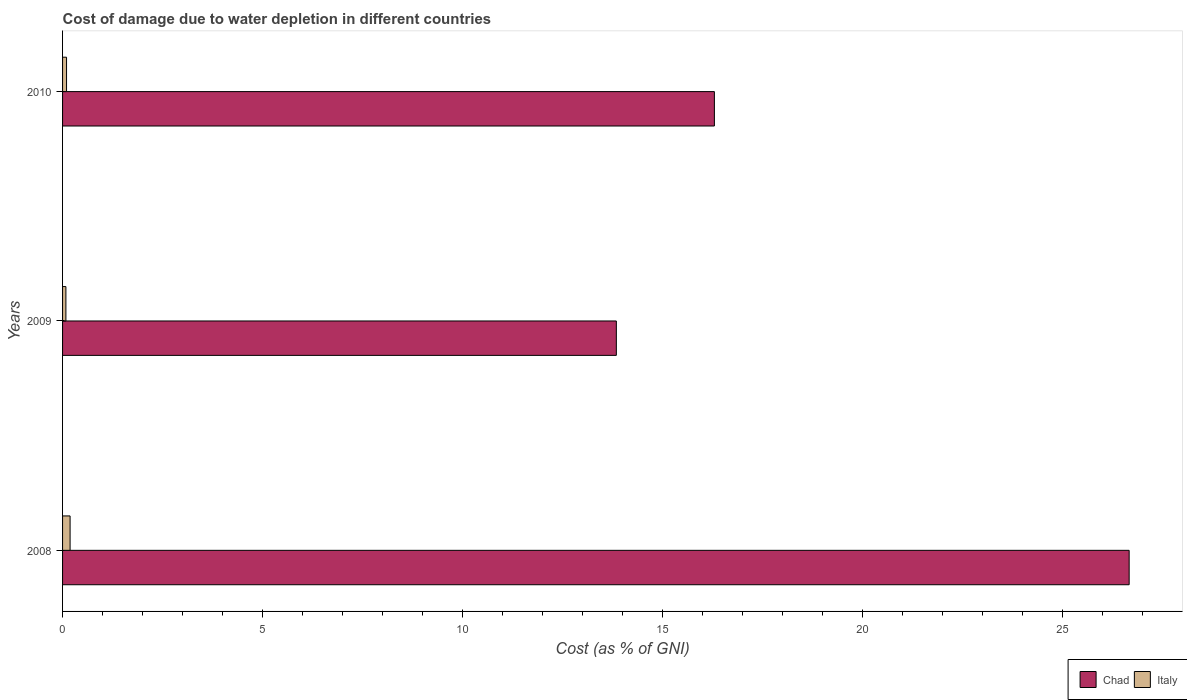How many groups of bars are there?
Your response must be concise. 3. Are the number of bars per tick equal to the number of legend labels?
Give a very brief answer. Yes. How many bars are there on the 3rd tick from the top?
Provide a short and direct response. 2. What is the label of the 1st group of bars from the top?
Give a very brief answer. 2010. In how many cases, is the number of bars for a given year not equal to the number of legend labels?
Ensure brevity in your answer.  0. What is the cost of damage caused due to water depletion in Italy in 2010?
Your response must be concise. 0.1. Across all years, what is the maximum cost of damage caused due to water depletion in Chad?
Make the answer very short. 26.66. Across all years, what is the minimum cost of damage caused due to water depletion in Chad?
Keep it short and to the point. 13.84. In which year was the cost of damage caused due to water depletion in Italy maximum?
Give a very brief answer. 2008. In which year was the cost of damage caused due to water depletion in Chad minimum?
Your answer should be compact. 2009. What is the total cost of damage caused due to water depletion in Chad in the graph?
Your response must be concise. 56.79. What is the difference between the cost of damage caused due to water depletion in Italy in 2008 and that in 2009?
Your response must be concise. 0.1. What is the difference between the cost of damage caused due to water depletion in Italy in 2009 and the cost of damage caused due to water depletion in Chad in 2008?
Your answer should be compact. -26.57. What is the average cost of damage caused due to water depletion in Italy per year?
Give a very brief answer. 0.12. In the year 2009, what is the difference between the cost of damage caused due to water depletion in Chad and cost of damage caused due to water depletion in Italy?
Your response must be concise. 13.76. What is the ratio of the cost of damage caused due to water depletion in Italy in 2008 to that in 2009?
Ensure brevity in your answer.  2.26. Is the difference between the cost of damage caused due to water depletion in Chad in 2009 and 2010 greater than the difference between the cost of damage caused due to water depletion in Italy in 2009 and 2010?
Give a very brief answer. No. What is the difference between the highest and the second highest cost of damage caused due to water depletion in Chad?
Your answer should be very brief. 10.37. What is the difference between the highest and the lowest cost of damage caused due to water depletion in Chad?
Keep it short and to the point. 12.82. In how many years, is the cost of damage caused due to water depletion in Chad greater than the average cost of damage caused due to water depletion in Chad taken over all years?
Offer a terse response. 1. Are all the bars in the graph horizontal?
Offer a very short reply. Yes. Does the graph contain any zero values?
Your response must be concise. No. Where does the legend appear in the graph?
Ensure brevity in your answer.  Bottom right. How many legend labels are there?
Your answer should be very brief. 2. How are the legend labels stacked?
Your answer should be very brief. Horizontal. What is the title of the graph?
Your answer should be compact. Cost of damage due to water depletion in different countries. Does "Iceland" appear as one of the legend labels in the graph?
Offer a very short reply. No. What is the label or title of the X-axis?
Provide a short and direct response. Cost (as % of GNI). What is the label or title of the Y-axis?
Offer a terse response. Years. What is the Cost (as % of GNI) of Chad in 2008?
Make the answer very short. 26.66. What is the Cost (as % of GNI) in Italy in 2008?
Offer a terse response. 0.19. What is the Cost (as % of GNI) in Chad in 2009?
Make the answer very short. 13.84. What is the Cost (as % of GNI) in Italy in 2009?
Your response must be concise. 0.08. What is the Cost (as % of GNI) in Chad in 2010?
Your response must be concise. 16.29. What is the Cost (as % of GNI) in Italy in 2010?
Provide a succinct answer. 0.1. Across all years, what is the maximum Cost (as % of GNI) in Chad?
Your answer should be compact. 26.66. Across all years, what is the maximum Cost (as % of GNI) of Italy?
Give a very brief answer. 0.19. Across all years, what is the minimum Cost (as % of GNI) of Chad?
Keep it short and to the point. 13.84. Across all years, what is the minimum Cost (as % of GNI) of Italy?
Your response must be concise. 0.08. What is the total Cost (as % of GNI) of Chad in the graph?
Provide a short and direct response. 56.79. What is the total Cost (as % of GNI) of Italy in the graph?
Ensure brevity in your answer.  0.37. What is the difference between the Cost (as % of GNI) of Chad in 2008 and that in 2009?
Provide a succinct answer. 12.82. What is the difference between the Cost (as % of GNI) of Italy in 2008 and that in 2009?
Keep it short and to the point. 0.1. What is the difference between the Cost (as % of GNI) in Chad in 2008 and that in 2010?
Offer a very short reply. 10.37. What is the difference between the Cost (as % of GNI) in Italy in 2008 and that in 2010?
Provide a succinct answer. 0.09. What is the difference between the Cost (as % of GNI) of Chad in 2009 and that in 2010?
Your answer should be very brief. -2.45. What is the difference between the Cost (as % of GNI) in Italy in 2009 and that in 2010?
Make the answer very short. -0.02. What is the difference between the Cost (as % of GNI) of Chad in 2008 and the Cost (as % of GNI) of Italy in 2009?
Offer a very short reply. 26.57. What is the difference between the Cost (as % of GNI) in Chad in 2008 and the Cost (as % of GNI) in Italy in 2010?
Keep it short and to the point. 26.56. What is the difference between the Cost (as % of GNI) in Chad in 2009 and the Cost (as % of GNI) in Italy in 2010?
Make the answer very short. 13.74. What is the average Cost (as % of GNI) in Chad per year?
Provide a succinct answer. 18.93. What is the average Cost (as % of GNI) in Italy per year?
Your answer should be compact. 0.12. In the year 2008, what is the difference between the Cost (as % of GNI) of Chad and Cost (as % of GNI) of Italy?
Your response must be concise. 26.47. In the year 2009, what is the difference between the Cost (as % of GNI) in Chad and Cost (as % of GNI) in Italy?
Your answer should be compact. 13.76. In the year 2010, what is the difference between the Cost (as % of GNI) in Chad and Cost (as % of GNI) in Italy?
Give a very brief answer. 16.19. What is the ratio of the Cost (as % of GNI) of Chad in 2008 to that in 2009?
Make the answer very short. 1.93. What is the ratio of the Cost (as % of GNI) in Italy in 2008 to that in 2009?
Give a very brief answer. 2.26. What is the ratio of the Cost (as % of GNI) of Chad in 2008 to that in 2010?
Provide a succinct answer. 1.64. What is the ratio of the Cost (as % of GNI) of Italy in 2008 to that in 2010?
Offer a terse response. 1.89. What is the ratio of the Cost (as % of GNI) of Chad in 2009 to that in 2010?
Make the answer very short. 0.85. What is the ratio of the Cost (as % of GNI) of Italy in 2009 to that in 2010?
Ensure brevity in your answer.  0.84. What is the difference between the highest and the second highest Cost (as % of GNI) in Chad?
Make the answer very short. 10.37. What is the difference between the highest and the second highest Cost (as % of GNI) of Italy?
Ensure brevity in your answer.  0.09. What is the difference between the highest and the lowest Cost (as % of GNI) in Chad?
Provide a succinct answer. 12.82. What is the difference between the highest and the lowest Cost (as % of GNI) of Italy?
Your response must be concise. 0.1. 